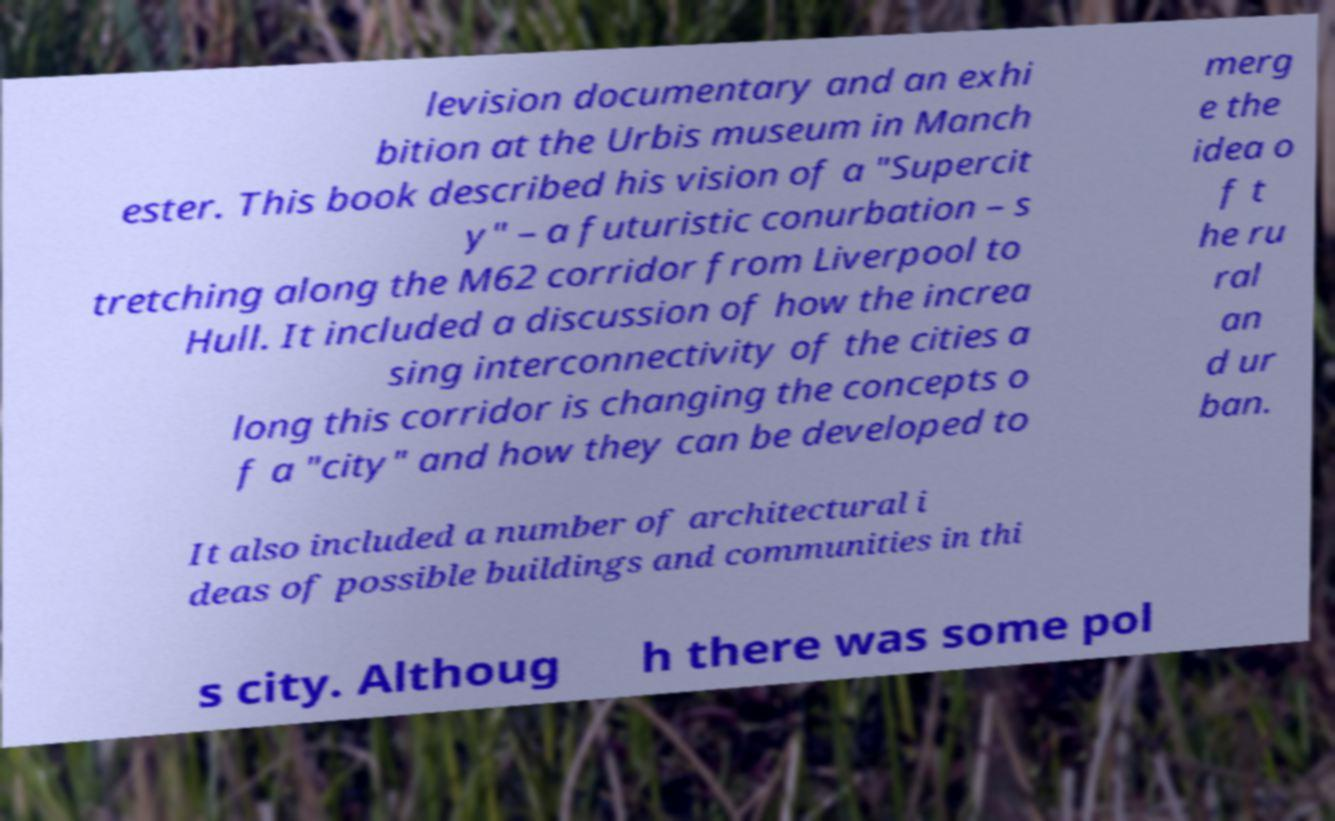Could you extract and type out the text from this image? levision documentary and an exhi bition at the Urbis museum in Manch ester. This book described his vision of a "Supercit y" – a futuristic conurbation – s tretching along the M62 corridor from Liverpool to Hull. It included a discussion of how the increa sing interconnectivity of the cities a long this corridor is changing the concepts o f a "city" and how they can be developed to merg e the idea o f t he ru ral an d ur ban. It also included a number of architectural i deas of possible buildings and communities in thi s city. Althoug h there was some pol 